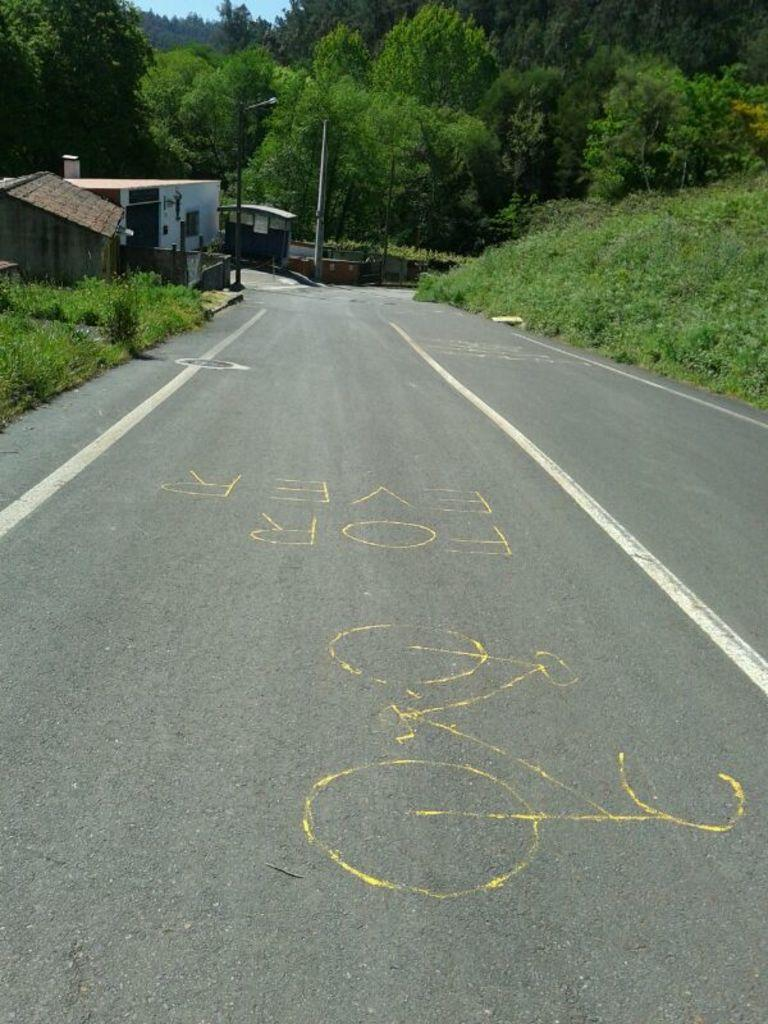What type of pathway is visible in the image? There is a road in the image. What structures can be seen alongside the road? There are small buildings in the image. What type of vegetation is present in the image? Trees are present in the image. What type of ground cover is visible in the image? Grass is visible in the image. Where is the lunchroom located in the image? There is no mention of a lunchroom in the image; it only features a road, small buildings, trees, and grass. 